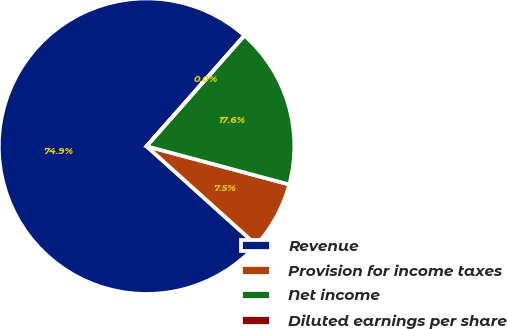Convert chart. <chart><loc_0><loc_0><loc_500><loc_500><pie_chart><fcel>Revenue<fcel>Provision for income taxes<fcel>Net income<fcel>Diluted earnings per share<nl><fcel>74.86%<fcel>7.49%<fcel>17.65%<fcel>0.0%<nl></chart> 